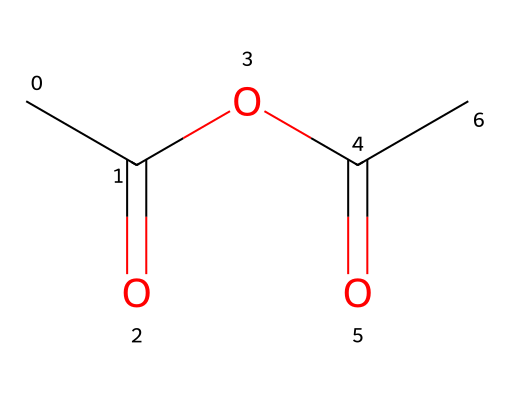How many carbon atoms are in acetic anhydride? The chemical structure shows that there are three carbon atoms, which can be counted directly from the SMILES representation.
Answer: three What functional groups are present in acetic anhydride? Acetic anhydride contains two acyl (carbonyl) groups and an ether link, identifiable by the presence of the carbonyl (C=O) and the ether (C-O-C) connections in the structure.
Answer: acyl and ether What is the molecular formula of acetic anhydride? By examining the chemical structure and counting the respective atoms, the molecular formula, including all carbon (C), hydrogen (H), and oxygen (O) atoms present, is determined to be C4H6O3.
Answer: C4H6O3 What type of reaction can acetic anhydride readily undergo? Acetic anhydride can undergo acylation reactions, which involve the transfer of an acyl group to another molecule, often seen in reactions with alcohols and amines.
Answer: acylation How many oxygen atoms are present in acetic anhydride? The structure reveals that there are three oxygen atoms; two are part of the carbonyl groups and one is part of the ether link. Thus, by straightforward counting, the answer is three.
Answer: three What is the significance of acetic anhydride in organic synthesis? Acetic anhydride is often used as a reagent for acetylation, which is important for modifying compounds in organic synthesis to achieve desired functionalities.
Answer: acetylation 